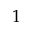Convert formula to latex. <formula><loc_0><loc_0><loc_500><loc_500>1</formula> 